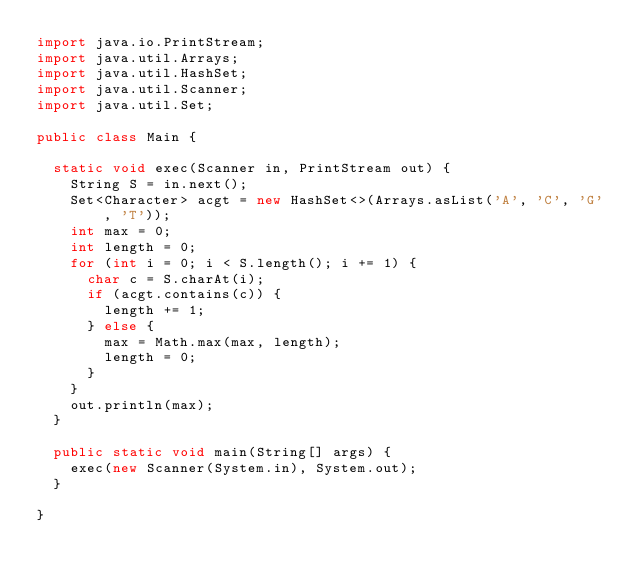<code> <loc_0><loc_0><loc_500><loc_500><_Java_>import java.io.PrintStream;
import java.util.Arrays;
import java.util.HashSet;
import java.util.Scanner;
import java.util.Set;

public class Main {

	static void exec(Scanner in, PrintStream out) {
		String S = in.next();
		Set<Character> acgt = new HashSet<>(Arrays.asList('A', 'C', 'G', 'T'));
		int max = 0;
		int length = 0;
		for (int i = 0; i < S.length(); i += 1) {
			char c = S.charAt(i);
			if (acgt.contains(c)) {
				length += 1;
			} else {
				max = Math.max(max, length);
				length = 0;
			}
		}
		out.println(max);
	}

	public static void main(String[] args) {
		exec(new Scanner(System.in), System.out);
	}

}
</code> 